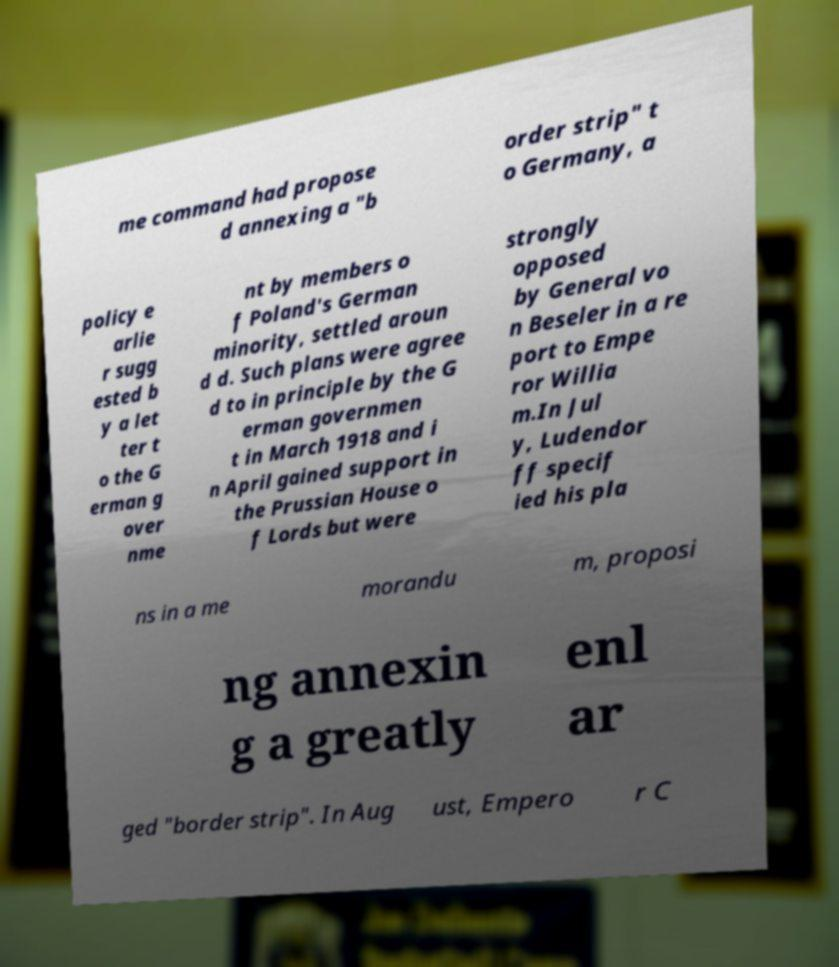Can you accurately transcribe the text from the provided image for me? me command had propose d annexing a "b order strip" t o Germany, a policy e arlie r sugg ested b y a let ter t o the G erman g over nme nt by members o f Poland's German minority, settled aroun d d. Such plans were agree d to in principle by the G erman governmen t in March 1918 and i n April gained support in the Prussian House o f Lords but were strongly opposed by General vo n Beseler in a re port to Empe ror Willia m.In Jul y, Ludendor ff specif ied his pla ns in a me morandu m, proposi ng annexin g a greatly enl ar ged "border strip". In Aug ust, Empero r C 